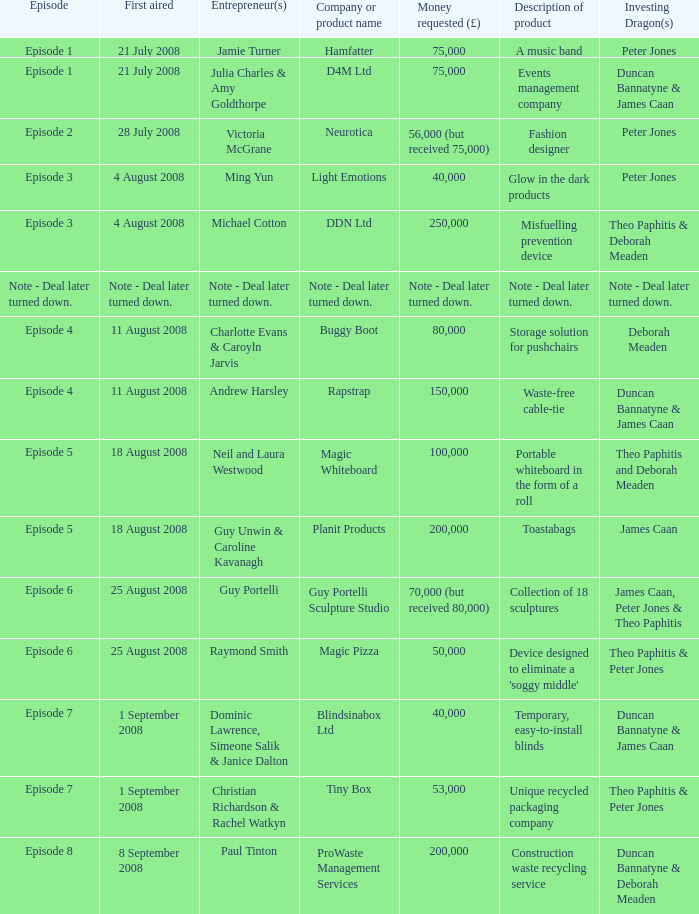Who is the corporation investing dragons, or little case? Theo Paphitis & Peter Jones. 